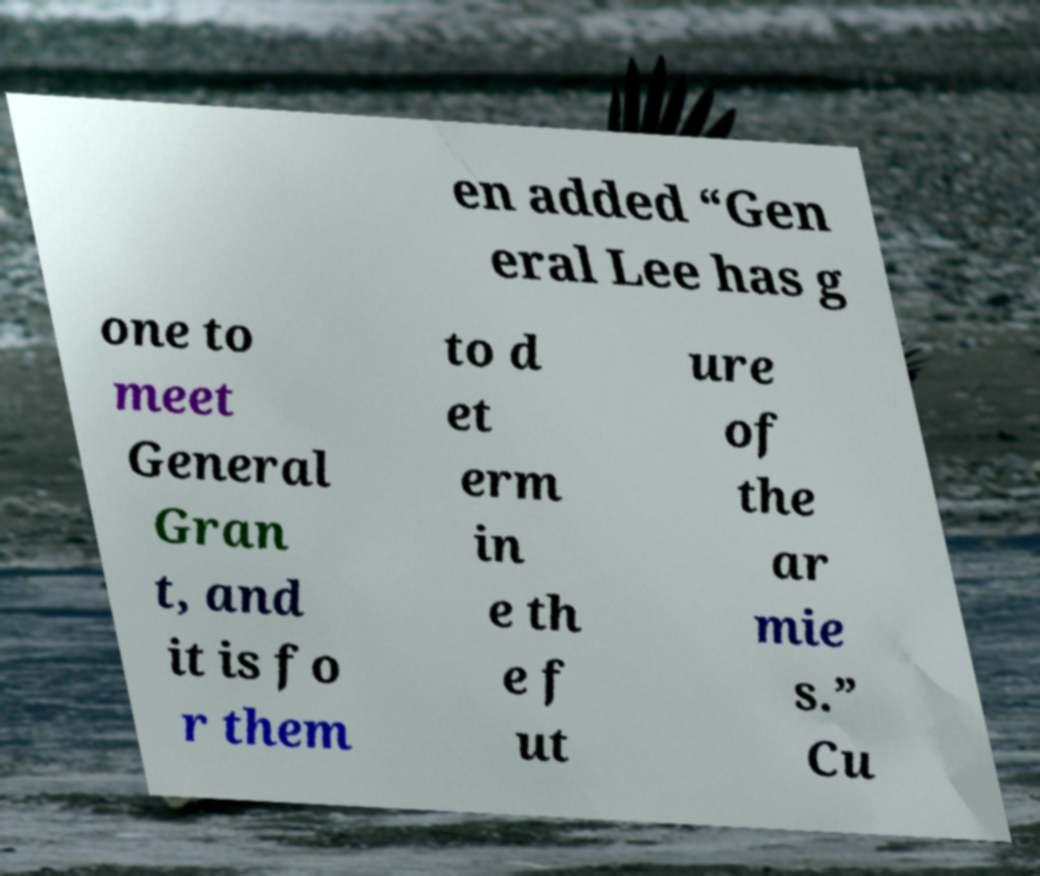Could you assist in decoding the text presented in this image and type it out clearly? en added “Gen eral Lee has g one to meet General Gran t, and it is fo r them to d et erm in e th e f ut ure of the ar mie s.” Cu 